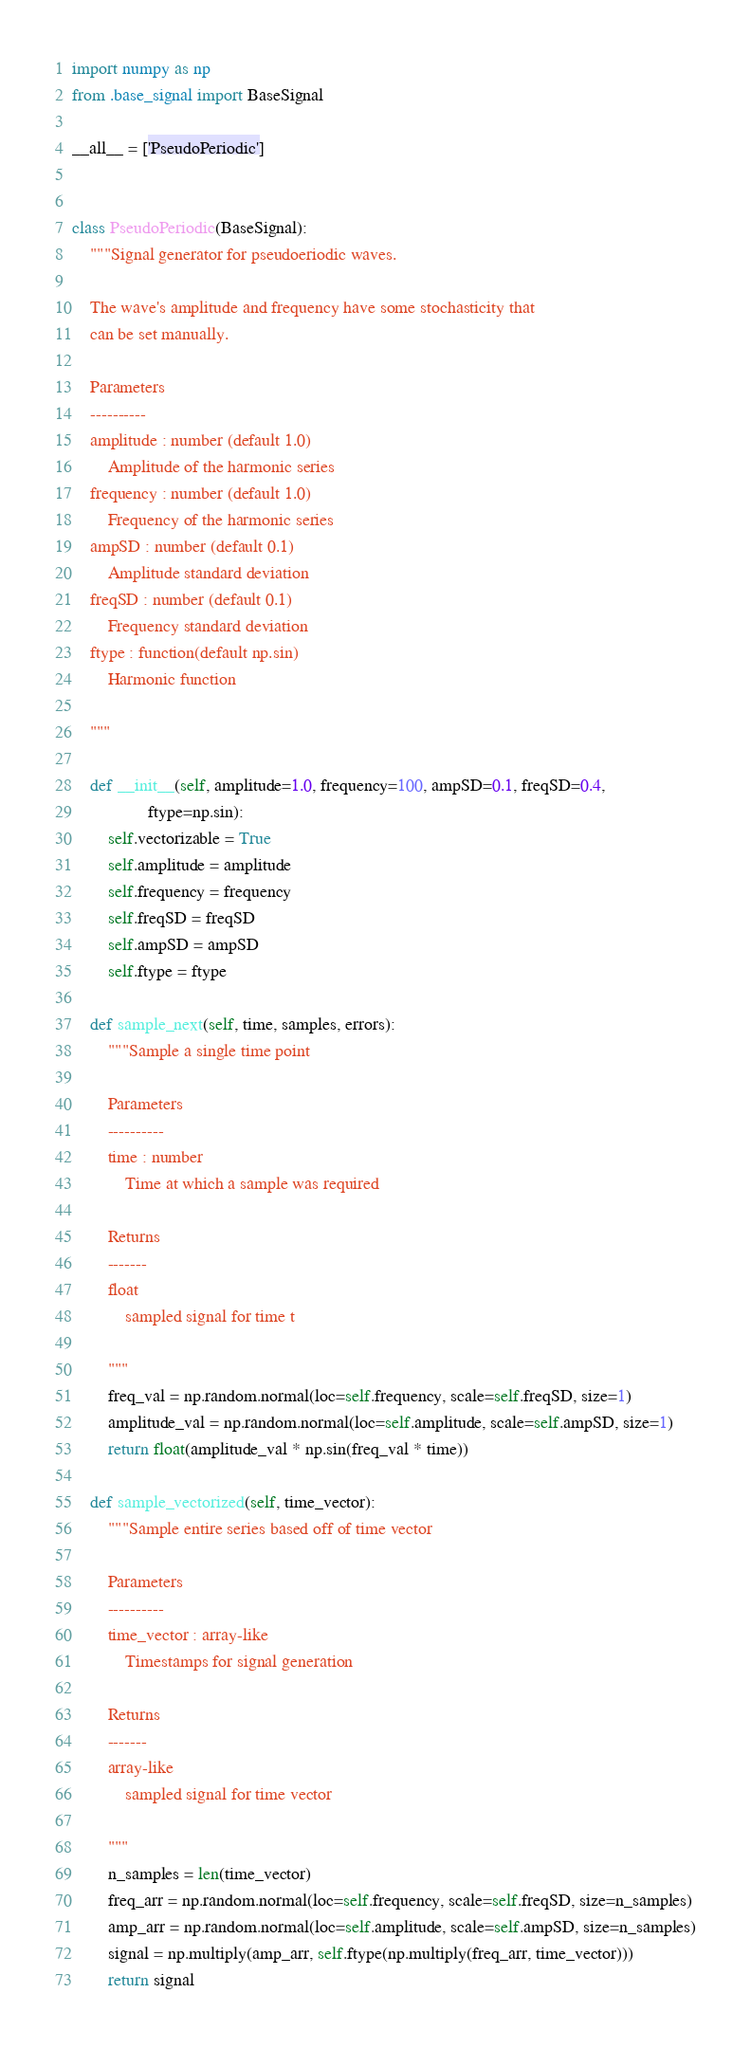<code> <loc_0><loc_0><loc_500><loc_500><_Python_>import numpy as np
from .base_signal import BaseSignal

__all__ = ['PseudoPeriodic']


class PseudoPeriodic(BaseSignal):
    """Signal generator for pseudoeriodic waves. 
    
    The wave's amplitude and frequency have some stochasticity that 
    can be set manually.

    Parameters
    ----------
    amplitude : number (default 1.0)
        Amplitude of the harmonic series
    frequency : number (default 1.0)
        Frequency of the harmonic series
    ampSD : number (default 0.1)
        Amplitude standard deviation
    freqSD : number (default 0.1)
        Frequency standard deviation
    ftype : function(default np.sin)
        Harmonic function
        
    """
    
    def __init__(self, amplitude=1.0, frequency=100, ampSD=0.1, freqSD=0.4,
                 ftype=np.sin):
        self.vectorizable = True
        self.amplitude = amplitude
        self.frequency = frequency
        self.freqSD = freqSD
        self.ampSD = ampSD
        self.ftype = ftype

    def sample_next(self, time, samples, errors):
        """Sample a single time point

        Parameters
        ----------
        time : number
            Time at which a sample was required

        Returns
        -------
        float
            sampled signal for time t

        """
        freq_val = np.random.normal(loc=self.frequency, scale=self.freqSD, size=1)
        amplitude_val = np.random.normal(loc=self.amplitude, scale=self.ampSD, size=1)
        return float(amplitude_val * np.sin(freq_val * time))

    def sample_vectorized(self, time_vector):
        """Sample entire series based off of time vector

        Parameters
        ----------
        time_vector : array-like
            Timestamps for signal generation

        Returns
        -------
        array-like
            sampled signal for time vector

        """
        n_samples = len(time_vector)
        freq_arr = np.random.normal(loc=self.frequency, scale=self.freqSD, size=n_samples)
        amp_arr = np.random.normal(loc=self.amplitude, scale=self.ampSD, size=n_samples)
        signal = np.multiply(amp_arr, self.ftype(np.multiply(freq_arr, time_vector)))
        return signal
</code> 